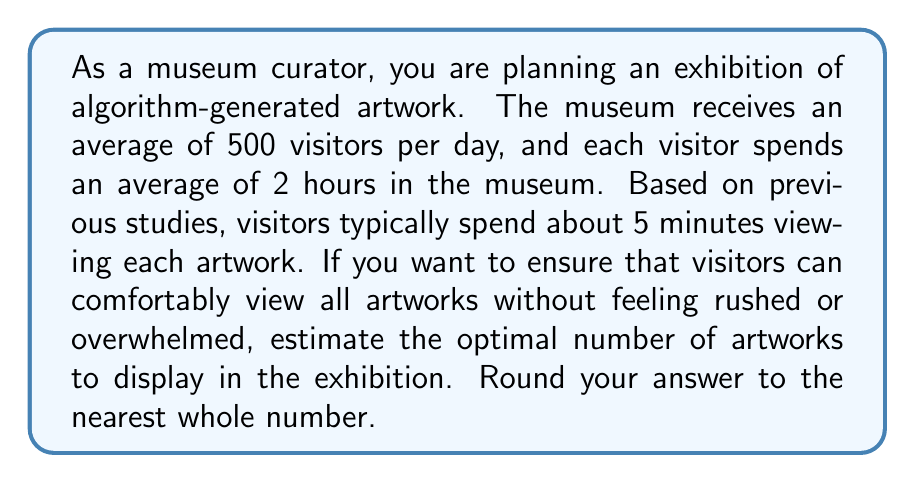Give your solution to this math problem. To solve this problem, we need to follow these steps:

1. Calculate the total visitor-hours per day:
   $$ \text{Total visitor-hours} = \text{Number of visitors} \times \text{Average time spent} $$
   $$ \text{Total visitor-hours} = 500 \times 2 = 1000 \text{ visitor-hours} $$

2. Convert the total visitor-hours to visitor-minutes:
   $$ \text{Total visitor-minutes} = 1000 \text{ visitor-hours} \times 60 \text{ minutes/hour} = 60000 \text{ visitor-minutes} $$

3. Calculate the total artwork-viewing capacity per day:
   $$ \text{Artwork-viewing capacity} = \frac{\text{Total visitor-minutes}}{\text{Time spent per artwork}} $$
   $$ \text{Artwork-viewing capacity} = \frac{60000 \text{ visitor-minutes}}{5 \text{ minutes/artwork}} = 12000 \text{ artwork views} $$

4. To find the optimal number of artworks, we divide the artwork-viewing capacity by the number of visitors:
   $$ \text{Optimal number of artworks} = \frac{\text{Artwork-viewing capacity}}{\text{Number of visitors}} $$
   $$ \text{Optimal number of artworks} = \frac{12000}{500} = 24 $$

Therefore, the optimal number of artworks to display is 24. This ensures that each visitor has the opportunity to view all artworks without feeling rushed, assuming an even distribution of visitors throughout the day.
Answer: 24 artworks 